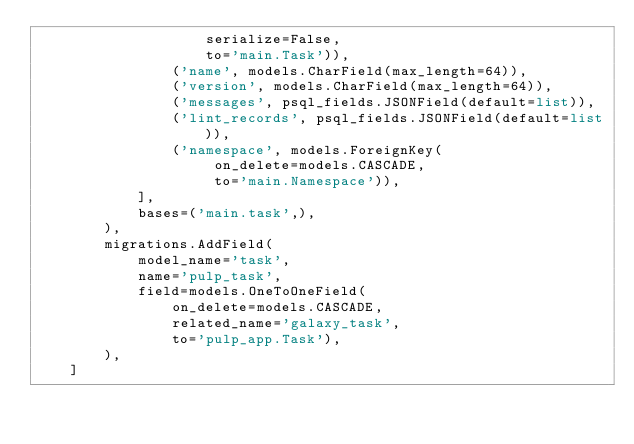<code> <loc_0><loc_0><loc_500><loc_500><_Python_>                    serialize=False,
                    to='main.Task')),
                ('name', models.CharField(max_length=64)),
                ('version', models.CharField(max_length=64)),
                ('messages', psql_fields.JSONField(default=list)),
                ('lint_records', psql_fields.JSONField(default=list)),
                ('namespace', models.ForeignKey(
                     on_delete=models.CASCADE,
                     to='main.Namespace')),
            ],
            bases=('main.task',),
        ),
        migrations.AddField(
            model_name='task',
            name='pulp_task',
            field=models.OneToOneField(
                on_delete=models.CASCADE,
                related_name='galaxy_task',
                to='pulp_app.Task'),
        ),
    ]
</code> 